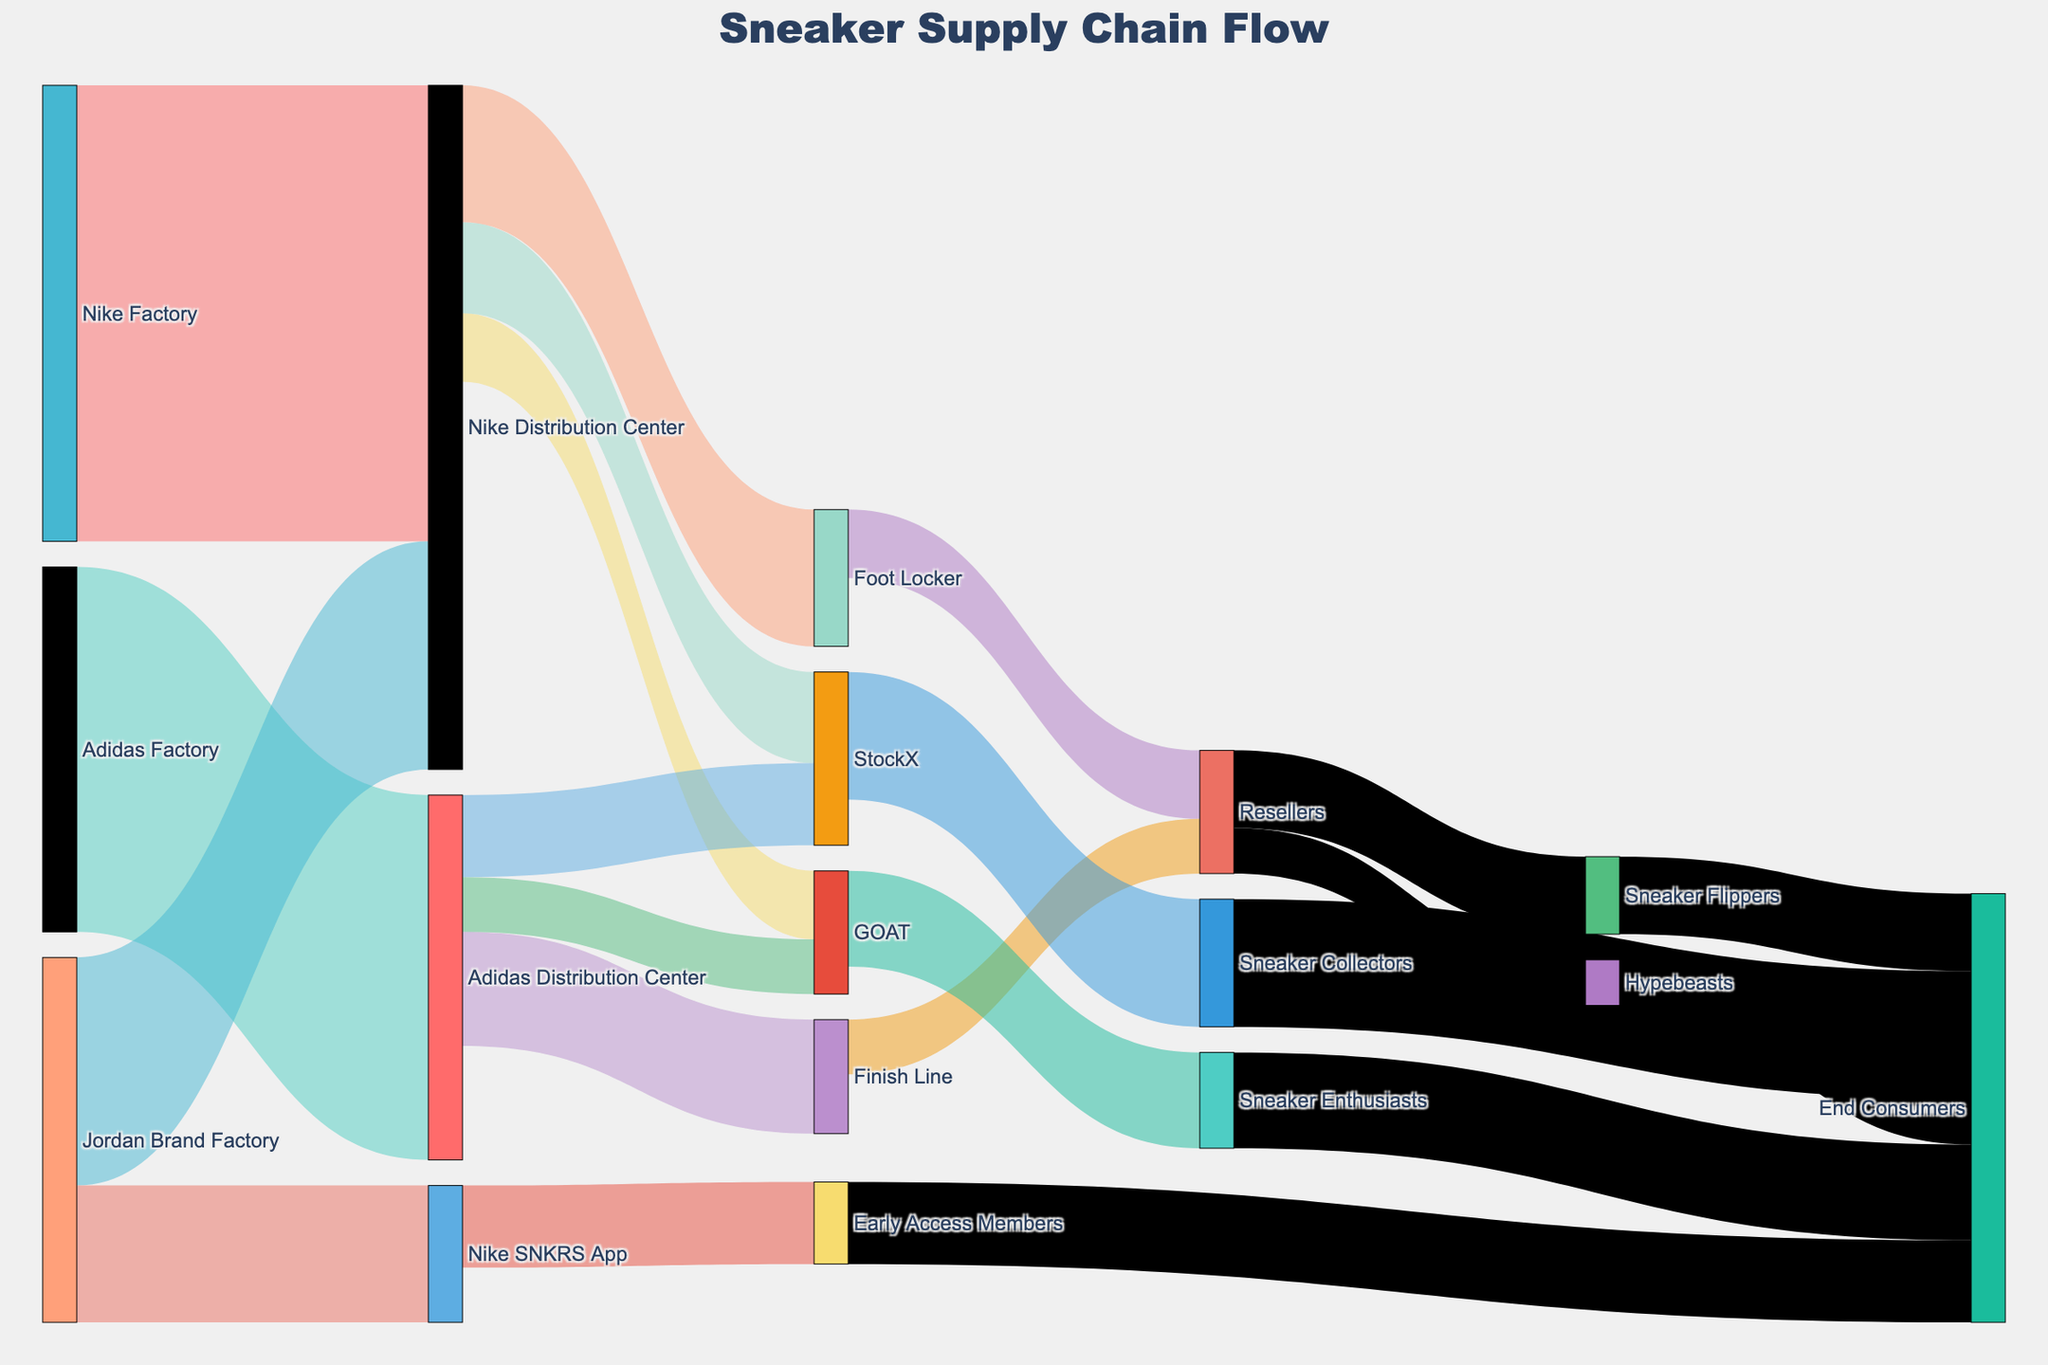What is the total number of sneakers that flowed from the Nike Distribution Center? To find the total number of sneakers that flowed from the Nike Distribution Center, sum the values of all outgoing flows from this node: Foot Locker (3000), StockX (2000), and GOAT (1500). So, 3000 + 2000 + 1500 = 6500.
Answer: 6500 Which channel receives the highest number of sneakers directly from the factories? To determine this, look at the flow values directly from the factories to various channels. The values are Nike Distribution Center (10000 from Nike Factory), Nike Distribution Center (5000 from Jordan Brand Factory), Adidas Distribution Center (8000 from Adidas Factory), and Nike SNKRS App (3000 from Jordan Brand Factory). The highest value here is 10000 from Nike Factory to Nike Distribution Center.
Answer: Nike Distribution Center from Nike Factory How many sneakers are handled by resellers in total? Sum up all the values for sneakers that flow into the "Resellers" node: Foot Locker (1500), Finish Line (1200). So, 1500 + 1200 = 2700.
Answer: 2700 Compare the number of sneakers that ultimately reach "End Consumers" from "Sneaker Collectors" versus from "Sneaker Enthusiasts". Which is higher? Observe the flows to "End Consumers": Sneakers from "Sneaker Collectors" are 2800, and from "Sneaker Enthusiasts" are 2100. The Sneakers from "Sneaker Collectors" are higher.
Answer: Sneaker Collectors What is the overall number of sneakers arriving at StockX from all sources? Sum the incoming flows to StockX: Nike Distribution Center (2000) and Adidas Distribution Center (1800). So 2000 + 1800 = 3800.
Answer: 3800 How many limited edition sneakers are supplied by the Adidas Factory in total? Look at the flows originating from the Adidas Factory: Adidas Distribution Center (8000).
Answer: 8000 Determine the flow with the least number of sneakers. What is it? Identify the flows with the smallest values: From Adidas Distribution Center to GOAT and from Resellers to Hypebeasts, both have 1000 sneakers.
Answer: Resellers to Hypebeasts or Adidas Distribution Center to GOAT Among the pairs of nodes participating in the flow to end consumers (Final nodes plus suppliers in the chain), which pair has the largest value? Sum the flows to end consumers and identify the largest contribution: Out of Resellers-Sneaker Flippers (1700), Hypebeasts (1000), Sneaker Collectors (2800), Sneaker Enthusiasts (2100), and Early Access Members (1800), Sneaker Collectors to End Consumers with 2800 is the largest.
Answer: Sneaker Collectors to End Consumers 